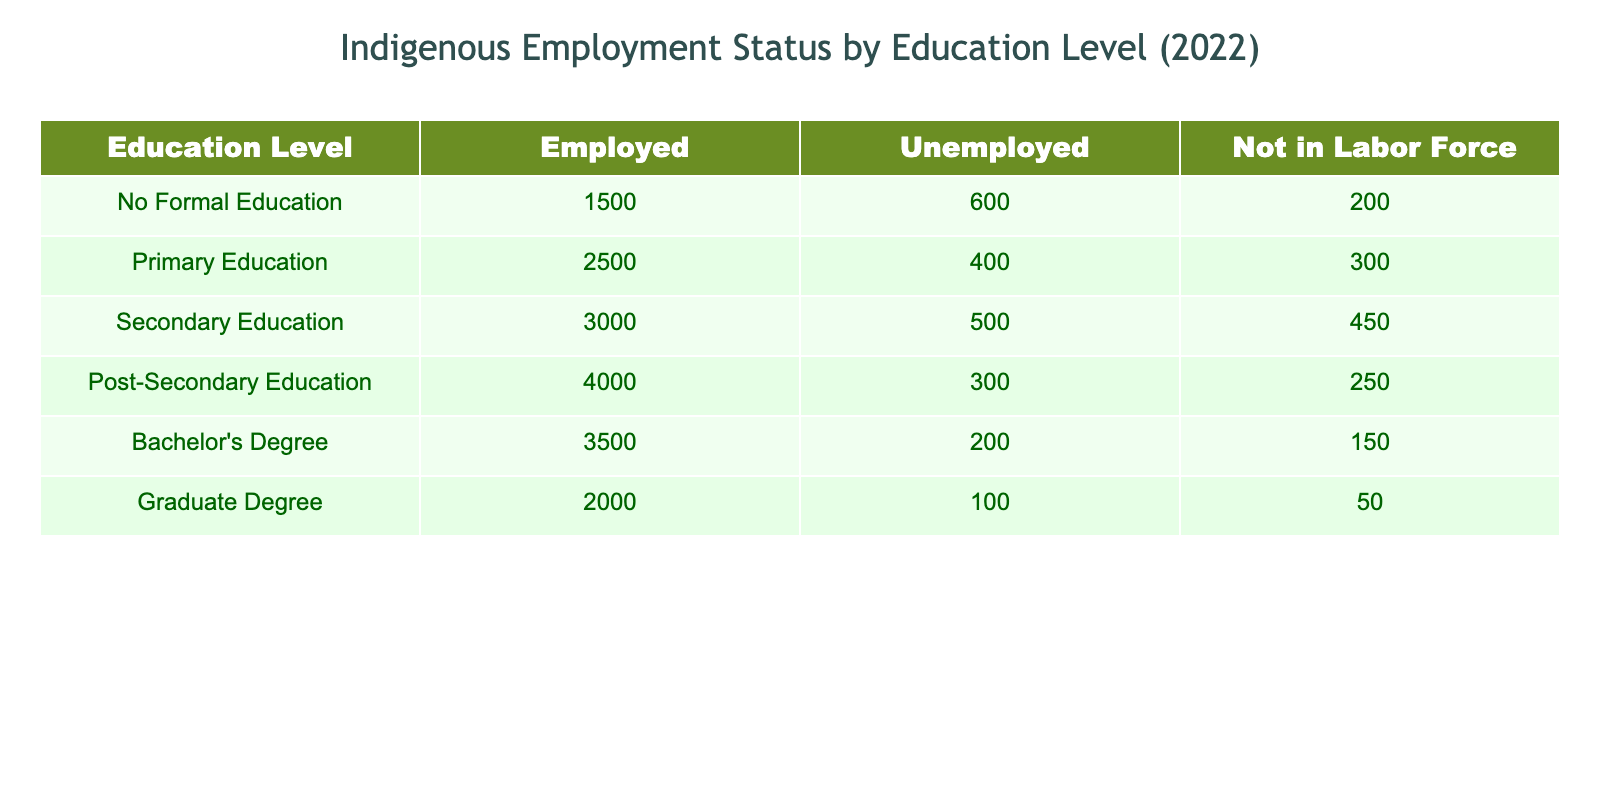What is the number of Indigenous individuals employed with a Graduate Degree? The table shows the value under 'Employed' for 'Graduate Degree' which is 2000.
Answer: 2000 How many people are Not in Labor Force with a Secondary Education? Looking at the 'Not in Labor Force' column for 'Secondary Education', the value is 450.
Answer: 450 What is the total number of Indigenous individuals employed across all education levels? To find this, I sum the values in the 'Employed' column: 1500 + 2500 + 3000 + 4000 + 3500 + 2000 = 19500.
Answer: 19500 Is the unemployment rate higher for individuals with No Formal Education compared to those with a Bachelor's Degree? The unemployment rate for No Formal Education is 600 out of (1500 + 600 + 200) = 2300, which is approximately 26.09%. For Bachelor's Degree, the unemployment rate is 200 out of (3500 + 200 + 150) = 3850, approximately 5.19%. Since 26.09% is greater than 5.19%, the answer is yes.
Answer: Yes What is the difference in the number of unemployed individuals between those with Primary Education and those with a Graduate Degree? The number of unemployed with Primary Education is 400, and for Graduate Degree, it is 100. Thus, the difference is 400 - 100 = 300.
Answer: 300 What percentage of individuals with Post-Secondary Education are Not in Labor Force? The number of individuals Not in Labor Force with Post-Secondary Education is 250, and the total with this education level is 4000 + 300 + 250 = 4550. To find the percentage: (250 / 4550) * 100 = 5.49%.
Answer: 5.49% How many individuals are employed across all education levels who are not in the labor force? First, sum 'Not in Labor Force' across all education levels: 200 + 300 + 450 + 250 + 150 + 50 = 1400.
Answer: 1400 With which education level do most Indigenous individuals find employment? Looking at the 'Employed' column, the highest value is 4000 for 'Post-Secondary Education'.
Answer: Post-Secondary Education How many Indigenous individuals are unemployed with Bachelor's Degree and No Formal Education combined? The total number of unemployed individuals in these categories is 600 (No Formal Education) + 200 (Bachelor's Degree) = 800.
Answer: 800 